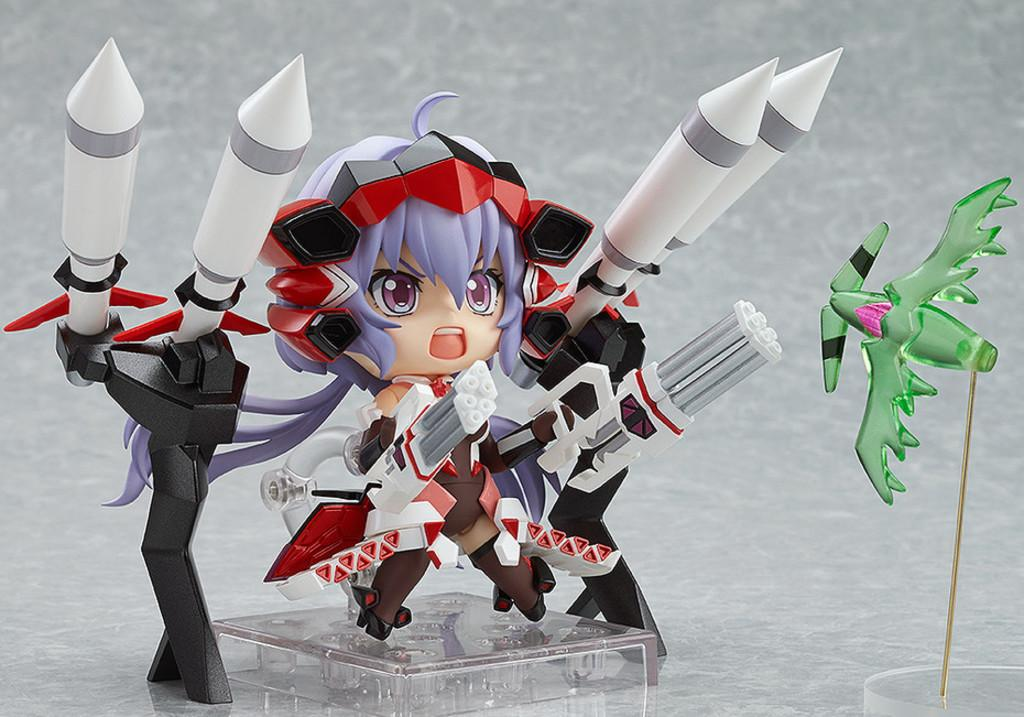What object in the image is designed for play or entertainment? There is a toy in the image. Can you see a snail crawling on the toy in the image? There is no snail present in the image; it only features a toy. 